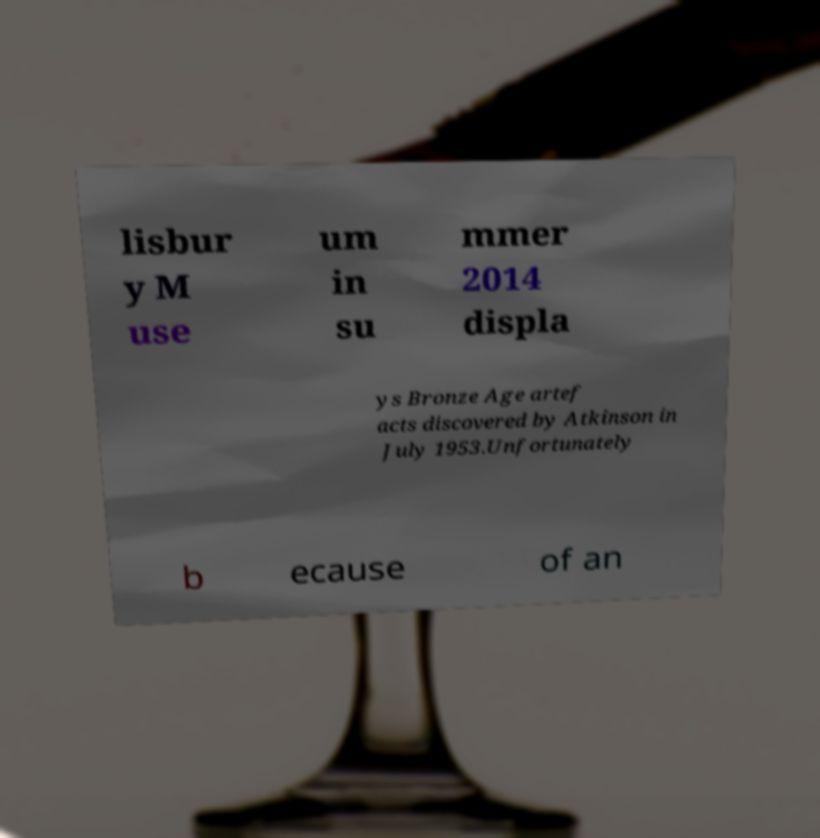For documentation purposes, I need the text within this image transcribed. Could you provide that? lisbur y M use um in su mmer 2014 displa ys Bronze Age artef acts discovered by Atkinson in July 1953.Unfortunately b ecause of an 